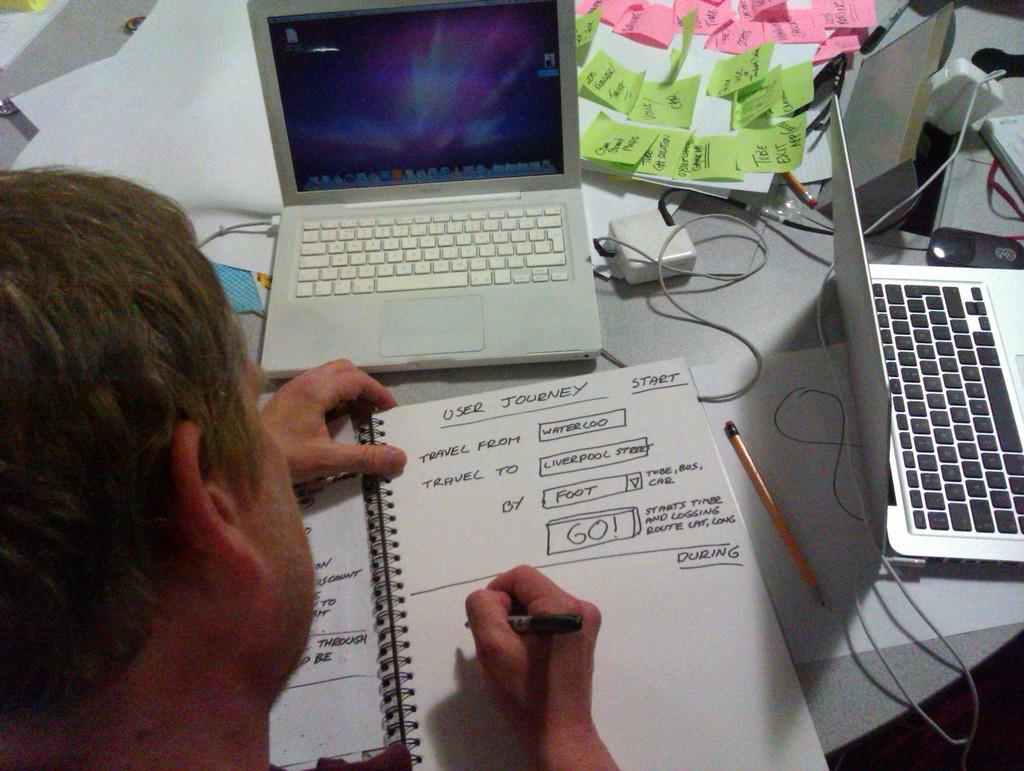What does it say in the large box on this sheet at the bottom?
Ensure brevity in your answer.  Go!. What does the top of the sheet of paper say?
Offer a very short reply. User journey. 